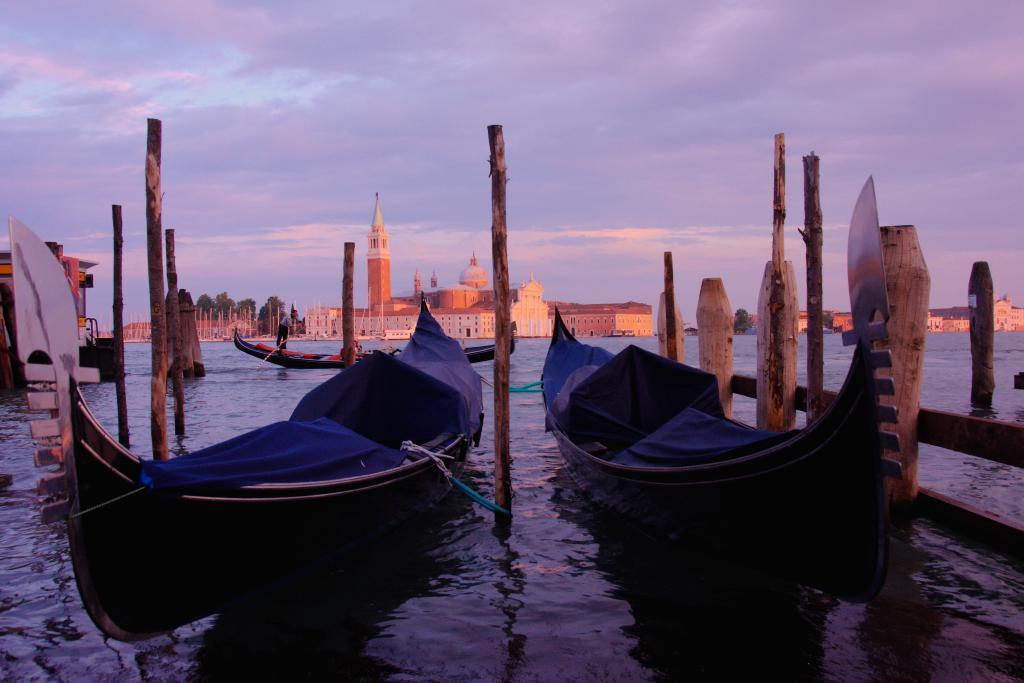Could you give a brief overview of what you see in this image? In this picture I can see many boats on the water, beside the boats I can see some wooden sticks. In the background I can see the trees, church, buildings and jeans. At the top I can see the sky and clouds. 